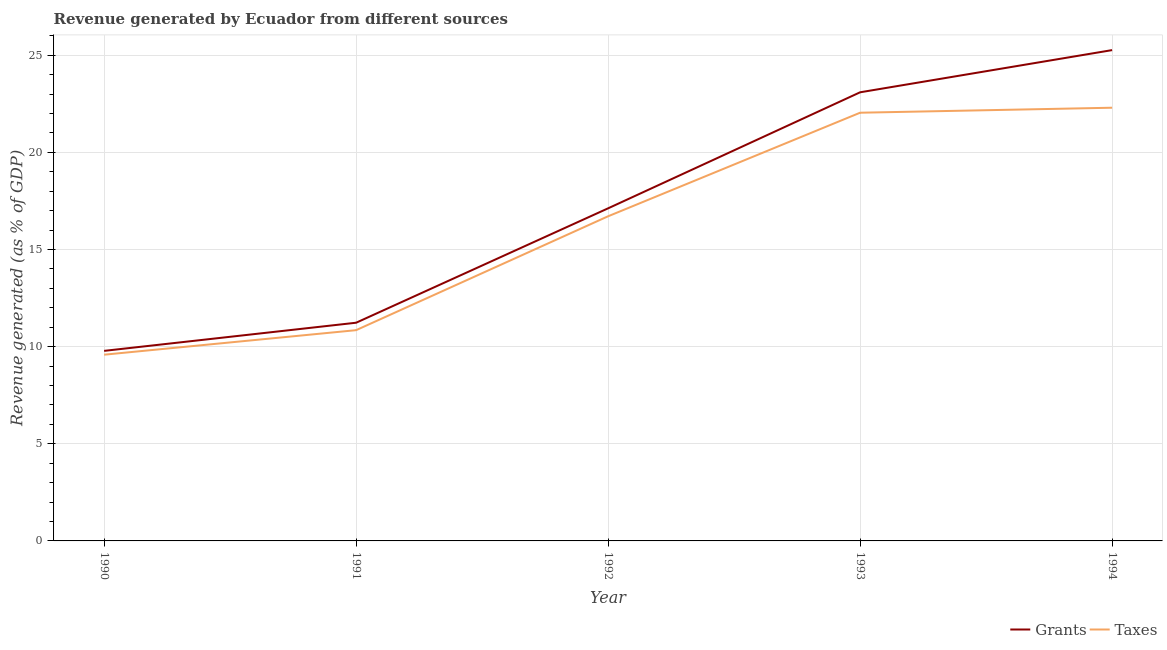What is the revenue generated by taxes in 1992?
Keep it short and to the point. 16.71. Across all years, what is the maximum revenue generated by taxes?
Offer a terse response. 22.3. Across all years, what is the minimum revenue generated by grants?
Provide a short and direct response. 9.78. In which year was the revenue generated by taxes maximum?
Your response must be concise. 1994. What is the total revenue generated by grants in the graph?
Provide a short and direct response. 86.49. What is the difference between the revenue generated by taxes in 1990 and that in 1994?
Provide a short and direct response. -12.71. What is the difference between the revenue generated by grants in 1991 and the revenue generated by taxes in 1993?
Your answer should be very brief. -10.81. What is the average revenue generated by grants per year?
Provide a succinct answer. 17.3. In the year 1991, what is the difference between the revenue generated by grants and revenue generated by taxes?
Keep it short and to the point. 0.38. What is the ratio of the revenue generated by grants in 1993 to that in 1994?
Make the answer very short. 0.91. What is the difference between the highest and the second highest revenue generated by taxes?
Ensure brevity in your answer.  0.26. What is the difference between the highest and the lowest revenue generated by taxes?
Offer a terse response. 12.71. In how many years, is the revenue generated by taxes greater than the average revenue generated by taxes taken over all years?
Provide a succinct answer. 3. Is the sum of the revenue generated by grants in 1991 and 1992 greater than the maximum revenue generated by taxes across all years?
Ensure brevity in your answer.  Yes. Does the revenue generated by grants monotonically increase over the years?
Keep it short and to the point. Yes. Is the revenue generated by taxes strictly greater than the revenue generated by grants over the years?
Your answer should be very brief. No. How many lines are there?
Give a very brief answer. 2. How many years are there in the graph?
Provide a short and direct response. 5. What is the difference between two consecutive major ticks on the Y-axis?
Give a very brief answer. 5. Where does the legend appear in the graph?
Offer a very short reply. Bottom right. How are the legend labels stacked?
Your response must be concise. Horizontal. What is the title of the graph?
Provide a short and direct response. Revenue generated by Ecuador from different sources. Does "Banks" appear as one of the legend labels in the graph?
Keep it short and to the point. No. What is the label or title of the X-axis?
Offer a terse response. Year. What is the label or title of the Y-axis?
Give a very brief answer. Revenue generated (as % of GDP). What is the Revenue generated (as % of GDP) in Grants in 1990?
Provide a succinct answer. 9.78. What is the Revenue generated (as % of GDP) of Taxes in 1990?
Provide a short and direct response. 9.59. What is the Revenue generated (as % of GDP) of Grants in 1991?
Offer a terse response. 11.23. What is the Revenue generated (as % of GDP) of Taxes in 1991?
Provide a short and direct response. 10.85. What is the Revenue generated (as % of GDP) of Grants in 1992?
Offer a terse response. 17.12. What is the Revenue generated (as % of GDP) in Taxes in 1992?
Your answer should be very brief. 16.71. What is the Revenue generated (as % of GDP) of Grants in 1993?
Keep it short and to the point. 23.09. What is the Revenue generated (as % of GDP) in Taxes in 1993?
Your answer should be compact. 22.04. What is the Revenue generated (as % of GDP) in Grants in 1994?
Ensure brevity in your answer.  25.26. What is the Revenue generated (as % of GDP) of Taxes in 1994?
Offer a very short reply. 22.3. Across all years, what is the maximum Revenue generated (as % of GDP) in Grants?
Offer a very short reply. 25.26. Across all years, what is the maximum Revenue generated (as % of GDP) in Taxes?
Keep it short and to the point. 22.3. Across all years, what is the minimum Revenue generated (as % of GDP) of Grants?
Ensure brevity in your answer.  9.78. Across all years, what is the minimum Revenue generated (as % of GDP) in Taxes?
Offer a very short reply. 9.59. What is the total Revenue generated (as % of GDP) of Grants in the graph?
Your answer should be compact. 86.49. What is the total Revenue generated (as % of GDP) in Taxes in the graph?
Your answer should be compact. 81.48. What is the difference between the Revenue generated (as % of GDP) of Grants in 1990 and that in 1991?
Provide a succinct answer. -1.45. What is the difference between the Revenue generated (as % of GDP) in Taxes in 1990 and that in 1991?
Provide a short and direct response. -1.26. What is the difference between the Revenue generated (as % of GDP) in Grants in 1990 and that in 1992?
Your response must be concise. -7.34. What is the difference between the Revenue generated (as % of GDP) in Taxes in 1990 and that in 1992?
Your response must be concise. -7.12. What is the difference between the Revenue generated (as % of GDP) in Grants in 1990 and that in 1993?
Your response must be concise. -13.31. What is the difference between the Revenue generated (as % of GDP) of Taxes in 1990 and that in 1993?
Ensure brevity in your answer.  -12.45. What is the difference between the Revenue generated (as % of GDP) of Grants in 1990 and that in 1994?
Your response must be concise. -15.48. What is the difference between the Revenue generated (as % of GDP) in Taxes in 1990 and that in 1994?
Provide a short and direct response. -12.71. What is the difference between the Revenue generated (as % of GDP) of Grants in 1991 and that in 1992?
Provide a short and direct response. -5.89. What is the difference between the Revenue generated (as % of GDP) in Taxes in 1991 and that in 1992?
Your answer should be very brief. -5.86. What is the difference between the Revenue generated (as % of GDP) in Grants in 1991 and that in 1993?
Offer a terse response. -11.86. What is the difference between the Revenue generated (as % of GDP) of Taxes in 1991 and that in 1993?
Make the answer very short. -11.19. What is the difference between the Revenue generated (as % of GDP) in Grants in 1991 and that in 1994?
Offer a very short reply. -14.03. What is the difference between the Revenue generated (as % of GDP) in Taxes in 1991 and that in 1994?
Give a very brief answer. -11.45. What is the difference between the Revenue generated (as % of GDP) of Grants in 1992 and that in 1993?
Keep it short and to the point. -5.97. What is the difference between the Revenue generated (as % of GDP) in Taxes in 1992 and that in 1993?
Provide a succinct answer. -5.33. What is the difference between the Revenue generated (as % of GDP) of Grants in 1992 and that in 1994?
Ensure brevity in your answer.  -8.14. What is the difference between the Revenue generated (as % of GDP) of Taxes in 1992 and that in 1994?
Make the answer very short. -5.59. What is the difference between the Revenue generated (as % of GDP) in Grants in 1993 and that in 1994?
Your answer should be compact. -2.17. What is the difference between the Revenue generated (as % of GDP) in Taxes in 1993 and that in 1994?
Ensure brevity in your answer.  -0.26. What is the difference between the Revenue generated (as % of GDP) in Grants in 1990 and the Revenue generated (as % of GDP) in Taxes in 1991?
Offer a terse response. -1.07. What is the difference between the Revenue generated (as % of GDP) in Grants in 1990 and the Revenue generated (as % of GDP) in Taxes in 1992?
Your response must be concise. -6.93. What is the difference between the Revenue generated (as % of GDP) of Grants in 1990 and the Revenue generated (as % of GDP) of Taxes in 1993?
Your response must be concise. -12.26. What is the difference between the Revenue generated (as % of GDP) in Grants in 1990 and the Revenue generated (as % of GDP) in Taxes in 1994?
Your answer should be very brief. -12.52. What is the difference between the Revenue generated (as % of GDP) of Grants in 1991 and the Revenue generated (as % of GDP) of Taxes in 1992?
Your answer should be compact. -5.48. What is the difference between the Revenue generated (as % of GDP) of Grants in 1991 and the Revenue generated (as % of GDP) of Taxes in 1993?
Provide a succinct answer. -10.81. What is the difference between the Revenue generated (as % of GDP) in Grants in 1991 and the Revenue generated (as % of GDP) in Taxes in 1994?
Keep it short and to the point. -11.07. What is the difference between the Revenue generated (as % of GDP) in Grants in 1992 and the Revenue generated (as % of GDP) in Taxes in 1993?
Offer a terse response. -4.92. What is the difference between the Revenue generated (as % of GDP) in Grants in 1992 and the Revenue generated (as % of GDP) in Taxes in 1994?
Provide a short and direct response. -5.18. What is the difference between the Revenue generated (as % of GDP) of Grants in 1993 and the Revenue generated (as % of GDP) of Taxes in 1994?
Your response must be concise. 0.79. What is the average Revenue generated (as % of GDP) in Grants per year?
Provide a succinct answer. 17.3. What is the average Revenue generated (as % of GDP) in Taxes per year?
Your answer should be compact. 16.3. In the year 1990, what is the difference between the Revenue generated (as % of GDP) of Grants and Revenue generated (as % of GDP) of Taxes?
Your answer should be very brief. 0.2. In the year 1991, what is the difference between the Revenue generated (as % of GDP) of Grants and Revenue generated (as % of GDP) of Taxes?
Your answer should be very brief. 0.38. In the year 1992, what is the difference between the Revenue generated (as % of GDP) in Grants and Revenue generated (as % of GDP) in Taxes?
Make the answer very short. 0.41. In the year 1993, what is the difference between the Revenue generated (as % of GDP) in Grants and Revenue generated (as % of GDP) in Taxes?
Give a very brief answer. 1.05. In the year 1994, what is the difference between the Revenue generated (as % of GDP) in Grants and Revenue generated (as % of GDP) in Taxes?
Provide a succinct answer. 2.97. What is the ratio of the Revenue generated (as % of GDP) in Grants in 1990 to that in 1991?
Provide a succinct answer. 0.87. What is the ratio of the Revenue generated (as % of GDP) of Taxes in 1990 to that in 1991?
Offer a very short reply. 0.88. What is the ratio of the Revenue generated (as % of GDP) in Grants in 1990 to that in 1992?
Offer a terse response. 0.57. What is the ratio of the Revenue generated (as % of GDP) of Taxes in 1990 to that in 1992?
Provide a short and direct response. 0.57. What is the ratio of the Revenue generated (as % of GDP) in Grants in 1990 to that in 1993?
Keep it short and to the point. 0.42. What is the ratio of the Revenue generated (as % of GDP) of Taxes in 1990 to that in 1993?
Make the answer very short. 0.43. What is the ratio of the Revenue generated (as % of GDP) of Grants in 1990 to that in 1994?
Your answer should be very brief. 0.39. What is the ratio of the Revenue generated (as % of GDP) in Taxes in 1990 to that in 1994?
Provide a short and direct response. 0.43. What is the ratio of the Revenue generated (as % of GDP) in Grants in 1991 to that in 1992?
Give a very brief answer. 0.66. What is the ratio of the Revenue generated (as % of GDP) in Taxes in 1991 to that in 1992?
Your answer should be very brief. 0.65. What is the ratio of the Revenue generated (as % of GDP) in Grants in 1991 to that in 1993?
Offer a very short reply. 0.49. What is the ratio of the Revenue generated (as % of GDP) of Taxes in 1991 to that in 1993?
Your response must be concise. 0.49. What is the ratio of the Revenue generated (as % of GDP) of Grants in 1991 to that in 1994?
Your answer should be very brief. 0.44. What is the ratio of the Revenue generated (as % of GDP) of Taxes in 1991 to that in 1994?
Give a very brief answer. 0.49. What is the ratio of the Revenue generated (as % of GDP) of Grants in 1992 to that in 1993?
Make the answer very short. 0.74. What is the ratio of the Revenue generated (as % of GDP) in Taxes in 1992 to that in 1993?
Your response must be concise. 0.76. What is the ratio of the Revenue generated (as % of GDP) of Grants in 1992 to that in 1994?
Keep it short and to the point. 0.68. What is the ratio of the Revenue generated (as % of GDP) in Taxes in 1992 to that in 1994?
Offer a terse response. 0.75. What is the ratio of the Revenue generated (as % of GDP) in Grants in 1993 to that in 1994?
Give a very brief answer. 0.91. What is the ratio of the Revenue generated (as % of GDP) of Taxes in 1993 to that in 1994?
Ensure brevity in your answer.  0.99. What is the difference between the highest and the second highest Revenue generated (as % of GDP) in Grants?
Keep it short and to the point. 2.17. What is the difference between the highest and the second highest Revenue generated (as % of GDP) in Taxes?
Your answer should be very brief. 0.26. What is the difference between the highest and the lowest Revenue generated (as % of GDP) of Grants?
Ensure brevity in your answer.  15.48. What is the difference between the highest and the lowest Revenue generated (as % of GDP) in Taxes?
Provide a short and direct response. 12.71. 